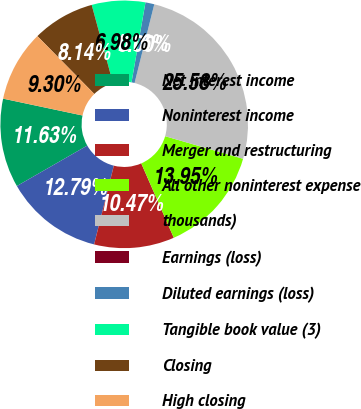Convert chart to OTSL. <chart><loc_0><loc_0><loc_500><loc_500><pie_chart><fcel>Net interest income<fcel>Noninterest income<fcel>Merger and restructuring<fcel>All other noninterest expense<fcel>thousands)<fcel>Earnings (loss)<fcel>Diluted earnings (loss)<fcel>Tangible book value (3)<fcel>Closing<fcel>High closing<nl><fcel>11.63%<fcel>12.79%<fcel>10.47%<fcel>13.95%<fcel>25.58%<fcel>0.0%<fcel>1.16%<fcel>6.98%<fcel>8.14%<fcel>9.3%<nl></chart> 